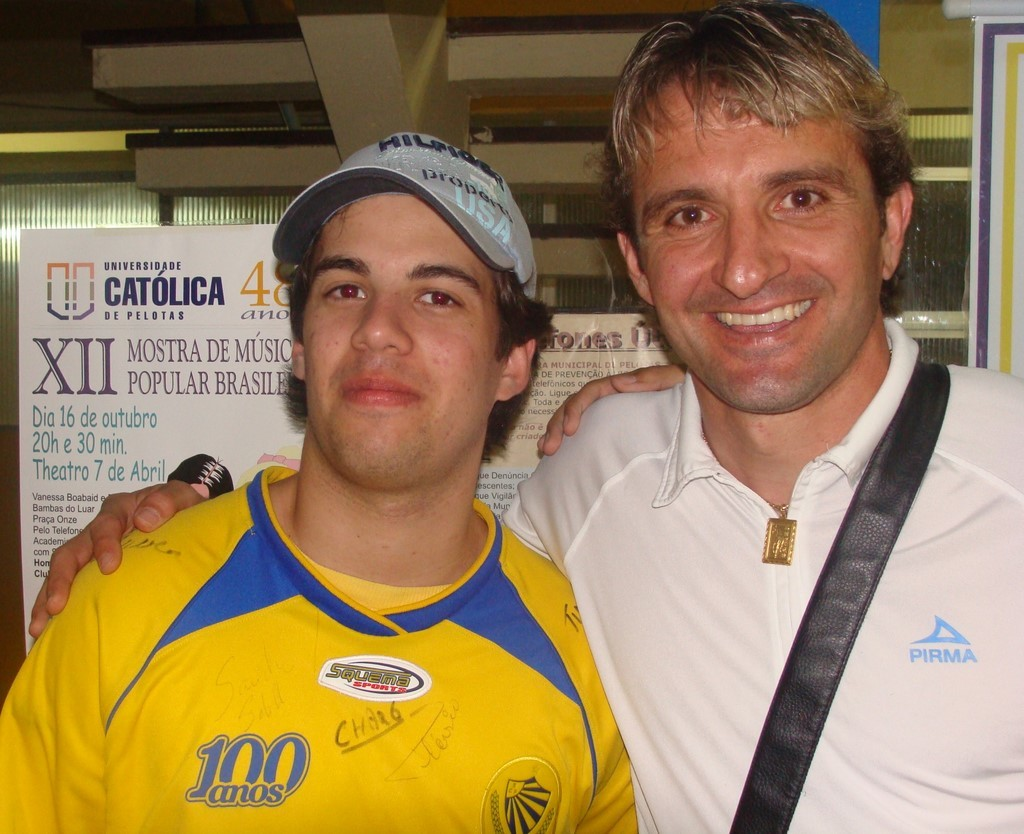Can you explain the significance of the signatures on the yellow shirt? The signatures on the yellow shirt likely belong to individuals who are either attendees or notable figures related to the event being celebrated, perhaps past or present students, faculty, or distinguished guests of the school or the music festival. This act is commonly seen in commemorations as a symbol of collective memory and honor. 